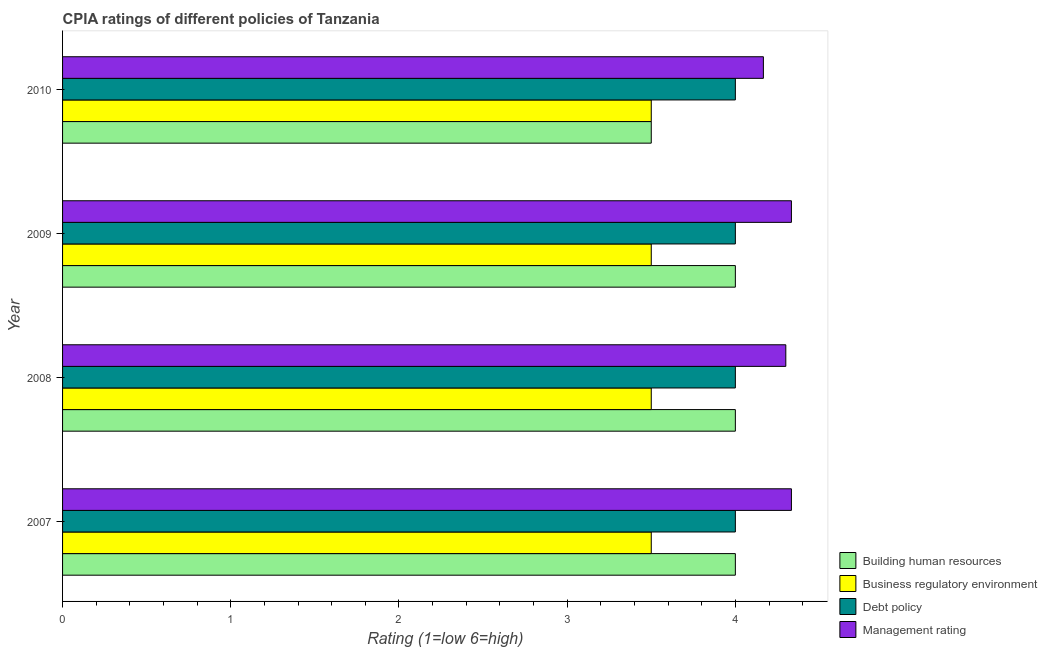How many different coloured bars are there?
Your answer should be compact. 4. Are the number of bars per tick equal to the number of legend labels?
Make the answer very short. Yes. In how many cases, is the number of bars for a given year not equal to the number of legend labels?
Provide a short and direct response. 0. What is the cpia rating of debt policy in 2007?
Offer a very short reply. 4. Across all years, what is the maximum cpia rating of business regulatory environment?
Give a very brief answer. 3.5. Across all years, what is the minimum cpia rating of debt policy?
Make the answer very short. 4. In which year was the cpia rating of building human resources maximum?
Your answer should be very brief. 2007. What is the total cpia rating of business regulatory environment in the graph?
Your response must be concise. 14. What is the difference between the cpia rating of management in 2009 and that in 2010?
Keep it short and to the point. 0.17. What is the difference between the cpia rating of debt policy in 2007 and the cpia rating of management in 2008?
Make the answer very short. -0.3. What is the average cpia rating of business regulatory environment per year?
Keep it short and to the point. 3.5. Is the difference between the cpia rating of management in 2008 and 2009 greater than the difference between the cpia rating of building human resources in 2008 and 2009?
Keep it short and to the point. No. What is the difference between the highest and the second highest cpia rating of building human resources?
Your answer should be compact. 0. What is the difference between the highest and the lowest cpia rating of management?
Ensure brevity in your answer.  0.17. Is the sum of the cpia rating of building human resources in 2007 and 2010 greater than the maximum cpia rating of debt policy across all years?
Provide a short and direct response. Yes. Is it the case that in every year, the sum of the cpia rating of debt policy and cpia rating of management is greater than the sum of cpia rating of building human resources and cpia rating of business regulatory environment?
Offer a very short reply. Yes. What does the 2nd bar from the top in 2007 represents?
Provide a short and direct response. Debt policy. What does the 2nd bar from the bottom in 2009 represents?
Give a very brief answer. Business regulatory environment. Is it the case that in every year, the sum of the cpia rating of building human resources and cpia rating of business regulatory environment is greater than the cpia rating of debt policy?
Keep it short and to the point. Yes. Are all the bars in the graph horizontal?
Make the answer very short. Yes. What is the difference between two consecutive major ticks on the X-axis?
Give a very brief answer. 1. Are the values on the major ticks of X-axis written in scientific E-notation?
Offer a very short reply. No. Does the graph contain grids?
Your response must be concise. No. Where does the legend appear in the graph?
Offer a very short reply. Bottom right. How are the legend labels stacked?
Your response must be concise. Vertical. What is the title of the graph?
Offer a very short reply. CPIA ratings of different policies of Tanzania. What is the Rating (1=low 6=high) in Debt policy in 2007?
Offer a terse response. 4. What is the Rating (1=low 6=high) of Management rating in 2007?
Provide a succinct answer. 4.33. What is the Rating (1=low 6=high) of Building human resources in 2008?
Your answer should be very brief. 4. What is the Rating (1=low 6=high) in Business regulatory environment in 2008?
Provide a succinct answer. 3.5. What is the Rating (1=low 6=high) in Debt policy in 2008?
Keep it short and to the point. 4. What is the Rating (1=low 6=high) in Management rating in 2008?
Your answer should be very brief. 4.3. What is the Rating (1=low 6=high) in Building human resources in 2009?
Provide a succinct answer. 4. What is the Rating (1=low 6=high) of Business regulatory environment in 2009?
Offer a very short reply. 3.5. What is the Rating (1=low 6=high) of Management rating in 2009?
Give a very brief answer. 4.33. What is the Rating (1=low 6=high) of Building human resources in 2010?
Keep it short and to the point. 3.5. What is the Rating (1=low 6=high) in Business regulatory environment in 2010?
Ensure brevity in your answer.  3.5. What is the Rating (1=low 6=high) of Debt policy in 2010?
Make the answer very short. 4. What is the Rating (1=low 6=high) in Management rating in 2010?
Ensure brevity in your answer.  4.17. Across all years, what is the maximum Rating (1=low 6=high) in Business regulatory environment?
Ensure brevity in your answer.  3.5. Across all years, what is the maximum Rating (1=low 6=high) in Debt policy?
Provide a short and direct response. 4. Across all years, what is the maximum Rating (1=low 6=high) in Management rating?
Offer a terse response. 4.33. Across all years, what is the minimum Rating (1=low 6=high) of Building human resources?
Your answer should be very brief. 3.5. Across all years, what is the minimum Rating (1=low 6=high) of Business regulatory environment?
Keep it short and to the point. 3.5. Across all years, what is the minimum Rating (1=low 6=high) in Management rating?
Keep it short and to the point. 4.17. What is the total Rating (1=low 6=high) of Building human resources in the graph?
Keep it short and to the point. 15.5. What is the total Rating (1=low 6=high) of Management rating in the graph?
Keep it short and to the point. 17.13. What is the difference between the Rating (1=low 6=high) of Building human resources in 2007 and that in 2008?
Ensure brevity in your answer.  0. What is the difference between the Rating (1=low 6=high) of Business regulatory environment in 2007 and that in 2008?
Ensure brevity in your answer.  0. What is the difference between the Rating (1=low 6=high) in Debt policy in 2007 and that in 2009?
Your answer should be very brief. 0. What is the difference between the Rating (1=low 6=high) in Building human resources in 2007 and that in 2010?
Make the answer very short. 0.5. What is the difference between the Rating (1=low 6=high) of Business regulatory environment in 2007 and that in 2010?
Provide a succinct answer. 0. What is the difference between the Rating (1=low 6=high) of Debt policy in 2007 and that in 2010?
Keep it short and to the point. 0. What is the difference between the Rating (1=low 6=high) of Management rating in 2007 and that in 2010?
Offer a very short reply. 0.17. What is the difference between the Rating (1=low 6=high) of Building human resources in 2008 and that in 2009?
Provide a succinct answer. 0. What is the difference between the Rating (1=low 6=high) in Management rating in 2008 and that in 2009?
Ensure brevity in your answer.  -0.03. What is the difference between the Rating (1=low 6=high) of Debt policy in 2008 and that in 2010?
Keep it short and to the point. 0. What is the difference between the Rating (1=low 6=high) in Management rating in 2008 and that in 2010?
Offer a very short reply. 0.13. What is the difference between the Rating (1=low 6=high) in Building human resources in 2009 and that in 2010?
Make the answer very short. 0.5. What is the difference between the Rating (1=low 6=high) of Building human resources in 2007 and the Rating (1=low 6=high) of Management rating in 2008?
Ensure brevity in your answer.  -0.3. What is the difference between the Rating (1=low 6=high) in Business regulatory environment in 2007 and the Rating (1=low 6=high) in Debt policy in 2008?
Your answer should be very brief. -0.5. What is the difference between the Rating (1=low 6=high) of Building human resources in 2007 and the Rating (1=low 6=high) of Business regulatory environment in 2009?
Keep it short and to the point. 0.5. What is the difference between the Rating (1=low 6=high) of Building human resources in 2007 and the Rating (1=low 6=high) of Debt policy in 2009?
Ensure brevity in your answer.  0. What is the difference between the Rating (1=low 6=high) in Business regulatory environment in 2007 and the Rating (1=low 6=high) in Debt policy in 2009?
Keep it short and to the point. -0.5. What is the difference between the Rating (1=low 6=high) in Building human resources in 2007 and the Rating (1=low 6=high) in Business regulatory environment in 2010?
Provide a short and direct response. 0.5. What is the difference between the Rating (1=low 6=high) in Building human resources in 2008 and the Rating (1=low 6=high) in Management rating in 2009?
Provide a short and direct response. -0.33. What is the difference between the Rating (1=low 6=high) in Business regulatory environment in 2008 and the Rating (1=low 6=high) in Management rating in 2009?
Your answer should be very brief. -0.83. What is the difference between the Rating (1=low 6=high) of Business regulatory environment in 2008 and the Rating (1=low 6=high) of Debt policy in 2010?
Provide a short and direct response. -0.5. What is the difference between the Rating (1=low 6=high) of Building human resources in 2009 and the Rating (1=low 6=high) of Debt policy in 2010?
Provide a succinct answer. 0. What is the difference between the Rating (1=low 6=high) of Building human resources in 2009 and the Rating (1=low 6=high) of Management rating in 2010?
Offer a very short reply. -0.17. What is the difference between the Rating (1=low 6=high) in Business regulatory environment in 2009 and the Rating (1=low 6=high) in Debt policy in 2010?
Offer a very short reply. -0.5. What is the difference between the Rating (1=low 6=high) of Debt policy in 2009 and the Rating (1=low 6=high) of Management rating in 2010?
Give a very brief answer. -0.17. What is the average Rating (1=low 6=high) of Building human resources per year?
Your answer should be very brief. 3.88. What is the average Rating (1=low 6=high) in Business regulatory environment per year?
Provide a succinct answer. 3.5. What is the average Rating (1=low 6=high) in Management rating per year?
Your answer should be very brief. 4.28. In the year 2007, what is the difference between the Rating (1=low 6=high) in Building human resources and Rating (1=low 6=high) in Business regulatory environment?
Provide a short and direct response. 0.5. In the year 2007, what is the difference between the Rating (1=low 6=high) of Debt policy and Rating (1=low 6=high) of Management rating?
Keep it short and to the point. -0.33. In the year 2008, what is the difference between the Rating (1=low 6=high) in Building human resources and Rating (1=low 6=high) in Business regulatory environment?
Ensure brevity in your answer.  0.5. In the year 2008, what is the difference between the Rating (1=low 6=high) in Building human resources and Rating (1=low 6=high) in Debt policy?
Your answer should be compact. 0. In the year 2008, what is the difference between the Rating (1=low 6=high) in Building human resources and Rating (1=low 6=high) in Management rating?
Your answer should be compact. -0.3. In the year 2008, what is the difference between the Rating (1=low 6=high) of Business regulatory environment and Rating (1=low 6=high) of Management rating?
Offer a terse response. -0.8. In the year 2008, what is the difference between the Rating (1=low 6=high) of Debt policy and Rating (1=low 6=high) of Management rating?
Provide a short and direct response. -0.3. In the year 2009, what is the difference between the Rating (1=low 6=high) in Building human resources and Rating (1=low 6=high) in Business regulatory environment?
Make the answer very short. 0.5. In the year 2009, what is the difference between the Rating (1=low 6=high) in Building human resources and Rating (1=low 6=high) in Debt policy?
Provide a succinct answer. 0. In the year 2009, what is the difference between the Rating (1=low 6=high) of Building human resources and Rating (1=low 6=high) of Management rating?
Offer a very short reply. -0.33. In the year 2010, what is the difference between the Rating (1=low 6=high) of Building human resources and Rating (1=low 6=high) of Business regulatory environment?
Your response must be concise. 0. In the year 2010, what is the difference between the Rating (1=low 6=high) in Building human resources and Rating (1=low 6=high) in Debt policy?
Your answer should be compact. -0.5. In the year 2010, what is the difference between the Rating (1=low 6=high) in Building human resources and Rating (1=low 6=high) in Management rating?
Your answer should be compact. -0.67. In the year 2010, what is the difference between the Rating (1=low 6=high) in Business regulatory environment and Rating (1=low 6=high) in Debt policy?
Keep it short and to the point. -0.5. In the year 2010, what is the difference between the Rating (1=low 6=high) in Business regulatory environment and Rating (1=low 6=high) in Management rating?
Offer a very short reply. -0.67. In the year 2010, what is the difference between the Rating (1=low 6=high) in Debt policy and Rating (1=low 6=high) in Management rating?
Your response must be concise. -0.17. What is the ratio of the Rating (1=low 6=high) in Business regulatory environment in 2007 to that in 2008?
Offer a terse response. 1. What is the ratio of the Rating (1=low 6=high) in Debt policy in 2007 to that in 2008?
Give a very brief answer. 1. What is the ratio of the Rating (1=low 6=high) in Building human resources in 2007 to that in 2009?
Your answer should be compact. 1. What is the ratio of the Rating (1=low 6=high) in Business regulatory environment in 2007 to that in 2010?
Offer a terse response. 1. What is the ratio of the Rating (1=low 6=high) in Debt policy in 2007 to that in 2010?
Provide a succinct answer. 1. What is the ratio of the Rating (1=low 6=high) of Management rating in 2008 to that in 2009?
Your response must be concise. 0.99. What is the ratio of the Rating (1=low 6=high) in Building human resources in 2008 to that in 2010?
Provide a short and direct response. 1.14. What is the ratio of the Rating (1=low 6=high) of Business regulatory environment in 2008 to that in 2010?
Your answer should be compact. 1. What is the ratio of the Rating (1=low 6=high) in Management rating in 2008 to that in 2010?
Provide a succinct answer. 1.03. What is the ratio of the Rating (1=low 6=high) in Debt policy in 2009 to that in 2010?
Provide a succinct answer. 1. What is the ratio of the Rating (1=low 6=high) in Management rating in 2009 to that in 2010?
Provide a succinct answer. 1.04. What is the difference between the highest and the lowest Rating (1=low 6=high) of Building human resources?
Keep it short and to the point. 0.5. What is the difference between the highest and the lowest Rating (1=low 6=high) in Management rating?
Provide a succinct answer. 0.17. 